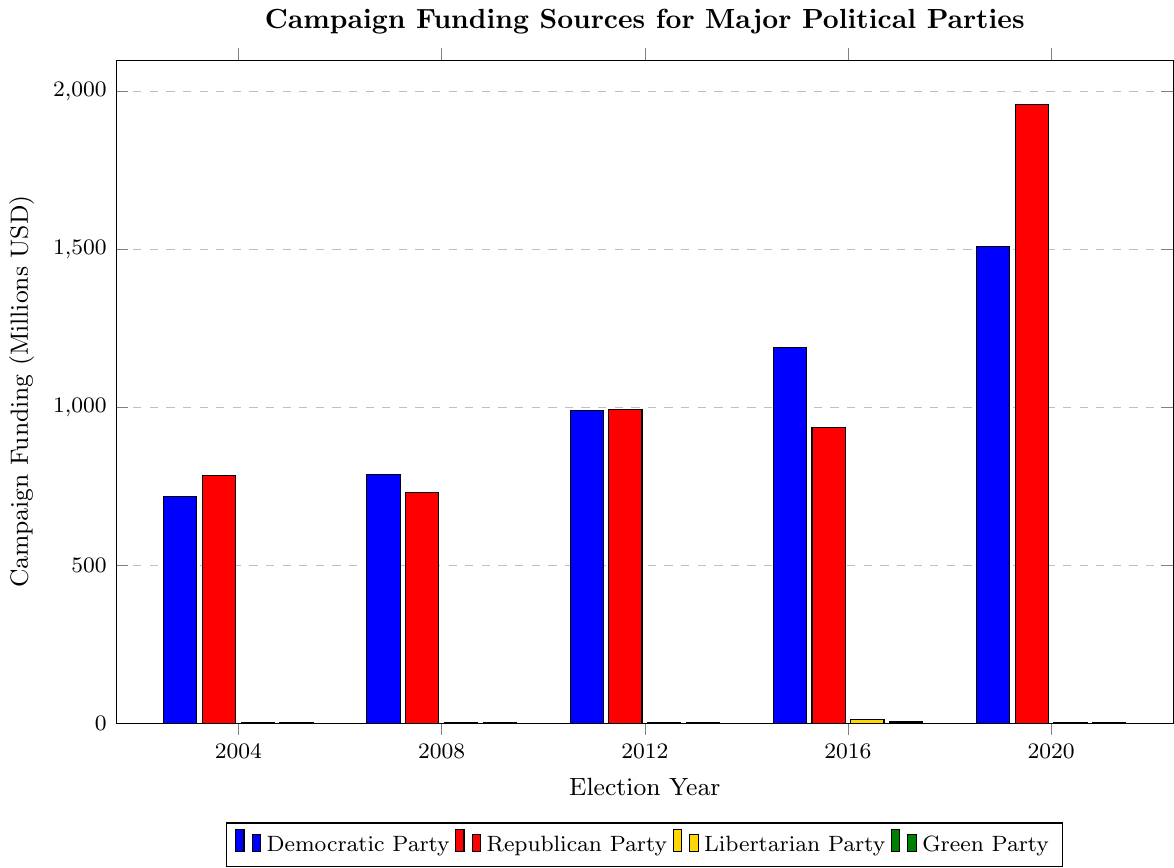Which political party received the highest campaign funding in the 2020 election cycle? Look for the tallest bar in the 2020 segment. The Republican Party's bar is the tallest.
Answer: Republican Party By how much did Democratic Party funding increase from 2016 to 2020? Subtract the 2016 value from the 2020 value for the Democratic Party: 1510 - 1191 = 319 million USD.
Answer: 319 million USD Which party had the lowest funding in the 2008 election cycle? Look for the shortest bar in the 2008 segment, which belongs to the Green Party.
Answer: Green Party What is the sum of campaign funding for the Libertarian Party over all five election cycles? Sum the Libertarian Party values: 1.2 + 1.4 + 2.5 + 12 + 2.9 = 20 million USD.
Answer: 20 million USD How did the campaign funding for the Green Party in 2016 compare to 2012? Subtract the 2012 value from the 2016 value for the Green Party: 3.5 - 0.9 = 2.6 million USD. The funding in 2016 was 2.6 million USD higher.
Answer: 2.6 million USD higher What is the average campaign funding for the Democratic Party across the five election cycles? Sum the funding for the Democratic Party and divide by 5: (718.5 + 788.6 + 989.1 + 1191 + 1510) / 5 = 1039.44 million USD.
Answer: 1039.44 million USD Which year(s) did the Republican Party receive less funding than the Democratic Party? Compare the heights of the bars for each election cycle:
- 2004: 784.8 (Rep) > 718.5 (Dem)
- 2008: 729.4 (Rep) < 788.6 (Dem)
- 2012: 992.1 (Rep) > 989.1 (Dem)
- 2016: 935.8 (Rep) < 1191 (Dem)
- 2020: 1960 (Rep) > 1510 (Dem)
So, the Republican Party received less funding in 2008 and 2016.
Answer: 2008, 2016 What's the total amount of campaign funding for both the Democratic and Republican parties combined in 2020? Sum the funding for Democratic and Republican parties in 2020: 1510 + 1960 = 3470 million USD.
Answer: 3470 million USD How has campaign funding for the Libertarian Party changed from 2004 to 2020? Calculate the difference between 2020 and 2004 funding for the Libertarian Party: 2.9 - 1.2 = 1.7 million USD. Funding increased by 1.7 million USD.
Answer: Increased by 1.7 million USD By how much did campaign funding for the Green Party fluctuate between the highest and lowest amounts over the five election cycles? Identify the highest (3.5 million in 2016) and lowest (0.8 million in 2004) values for the Green Party; then calculate the difference: 3.5 - 0.8 = 2.7 million USD.
Answer: 2.7 million USD 